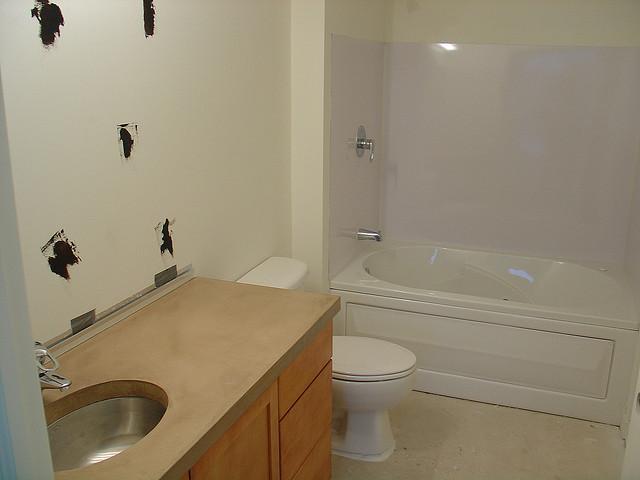How many mirrors?
Give a very brief answer. 0. 